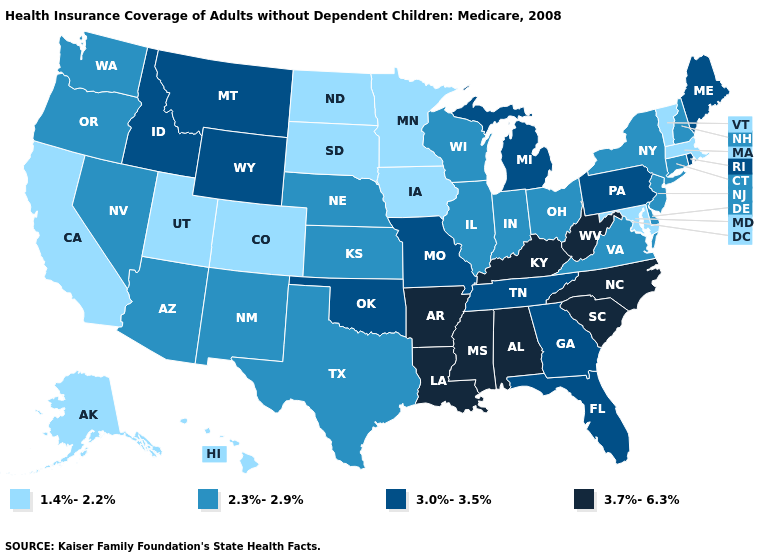What is the highest value in the Northeast ?
Give a very brief answer. 3.0%-3.5%. What is the value of Alaska?
Give a very brief answer. 1.4%-2.2%. Does Mississippi have the same value as Kentucky?
Concise answer only. Yes. Which states have the lowest value in the South?
Answer briefly. Maryland. Does New York have the highest value in the Northeast?
Short answer required. No. Which states have the lowest value in the Northeast?
Short answer required. Massachusetts, Vermont. Does Louisiana have the highest value in the USA?
Keep it brief. Yes. What is the value of California?
Quick response, please. 1.4%-2.2%. Among the states that border Georgia , which have the highest value?
Concise answer only. Alabama, North Carolina, South Carolina. What is the value of Oklahoma?
Give a very brief answer. 3.0%-3.5%. Name the states that have a value in the range 2.3%-2.9%?
Write a very short answer. Arizona, Connecticut, Delaware, Illinois, Indiana, Kansas, Nebraska, Nevada, New Hampshire, New Jersey, New Mexico, New York, Ohio, Oregon, Texas, Virginia, Washington, Wisconsin. Among the states that border Tennessee , does Kentucky have the highest value?
Quick response, please. Yes. How many symbols are there in the legend?
Answer briefly. 4. Which states have the lowest value in the USA?
Answer briefly. Alaska, California, Colorado, Hawaii, Iowa, Maryland, Massachusetts, Minnesota, North Dakota, South Dakota, Utah, Vermont. What is the value of Washington?
Quick response, please. 2.3%-2.9%. 